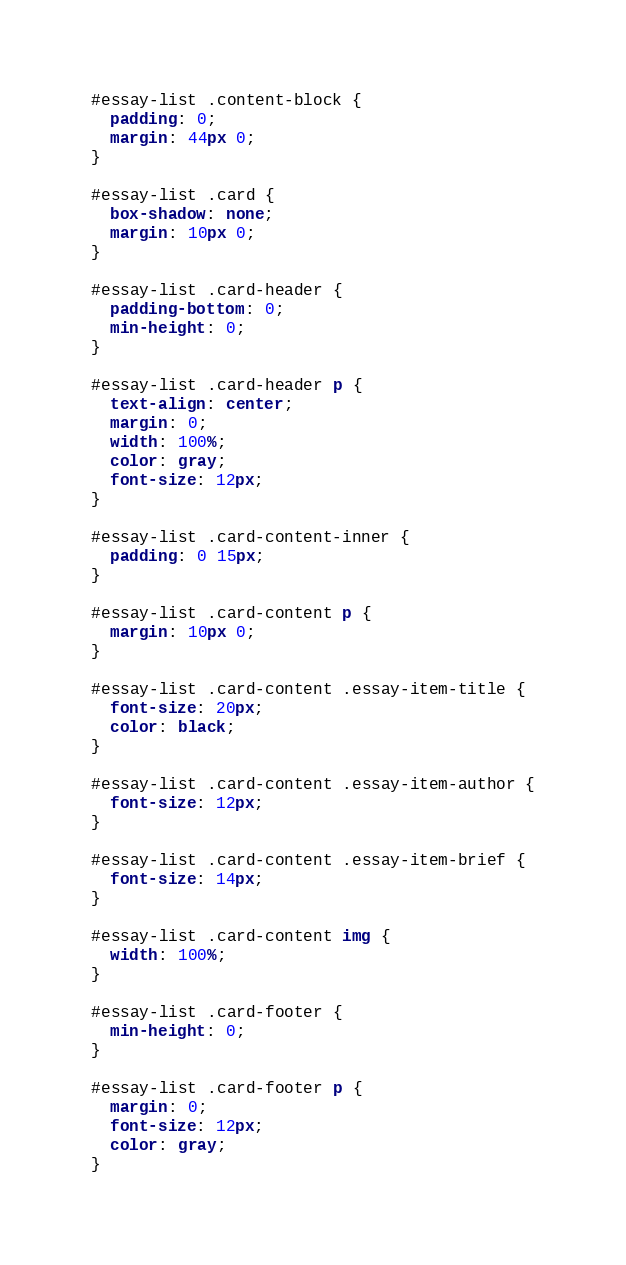Convert code to text. <code><loc_0><loc_0><loc_500><loc_500><_CSS_>#essay-list .content-block {
  padding: 0;
  margin: 44px 0;
}

#essay-list .card {
  box-shadow: none;
  margin: 10px 0;
}

#essay-list .card-header {
  padding-bottom: 0;
  min-height: 0;
}

#essay-list .card-header p {
  text-align: center;
  margin: 0;
  width: 100%;
  color: gray;
  font-size: 12px;
}

#essay-list .card-content-inner {
  padding: 0 15px;
}

#essay-list .card-content p {
  margin: 10px 0;
}

#essay-list .card-content .essay-item-title {
  font-size: 20px;
  color: black;
}

#essay-list .card-content .essay-item-author {
  font-size: 12px;
}

#essay-list .card-content .essay-item-brief {
  font-size: 14px;
}

#essay-list .card-content img {
  width: 100%;
}

#essay-list .card-footer {
  min-height: 0;
}

#essay-list .card-footer p {
  margin: 0;
  font-size: 12px;
  color: gray;
}
</code> 